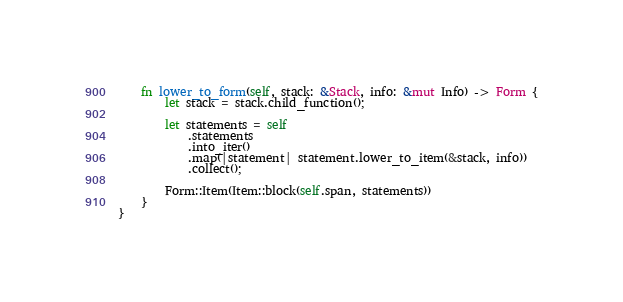Convert code to text. <code><loc_0><loc_0><loc_500><loc_500><_Rust_>    fn lower_to_form(self, stack: &Stack, info: &mut Info) -> Form {
        let stack = stack.child_function();

        let statements = self
            .statements
            .into_iter()
            .map(|statement| statement.lower_to_item(&stack, info))
            .collect();

        Form::Item(Item::block(self.span, statements))
    }
}
</code> 